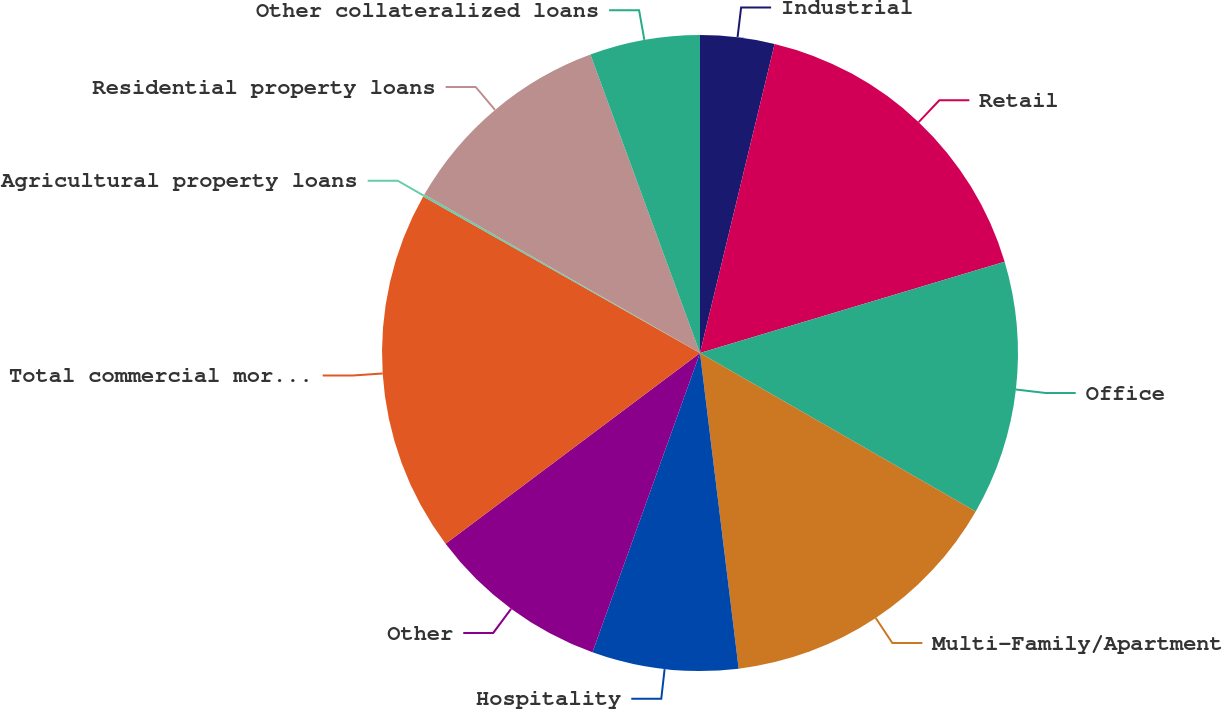<chart> <loc_0><loc_0><loc_500><loc_500><pie_chart><fcel>Industrial<fcel>Retail<fcel>Office<fcel>Multi-Family/Apartment<fcel>Hospitality<fcel>Other<fcel>Total commercial mortgage<fcel>Agricultural property loans<fcel>Residential property loans<fcel>Other collateralized loans<nl><fcel>3.77%<fcel>16.6%<fcel>12.93%<fcel>14.76%<fcel>7.43%<fcel>9.27%<fcel>18.43%<fcel>0.11%<fcel>11.1%<fcel>5.6%<nl></chart> 